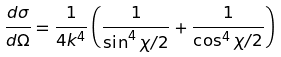<formula> <loc_0><loc_0><loc_500><loc_500>\frac { d \sigma } { d \Omega } = \frac { 1 } { 4 k ^ { 4 } } \left ( \frac { 1 } { \sin ^ { 4 } { \chi / 2 } } + \frac { 1 } { \cos ^ { 4 } { \chi / 2 } } \right )</formula> 